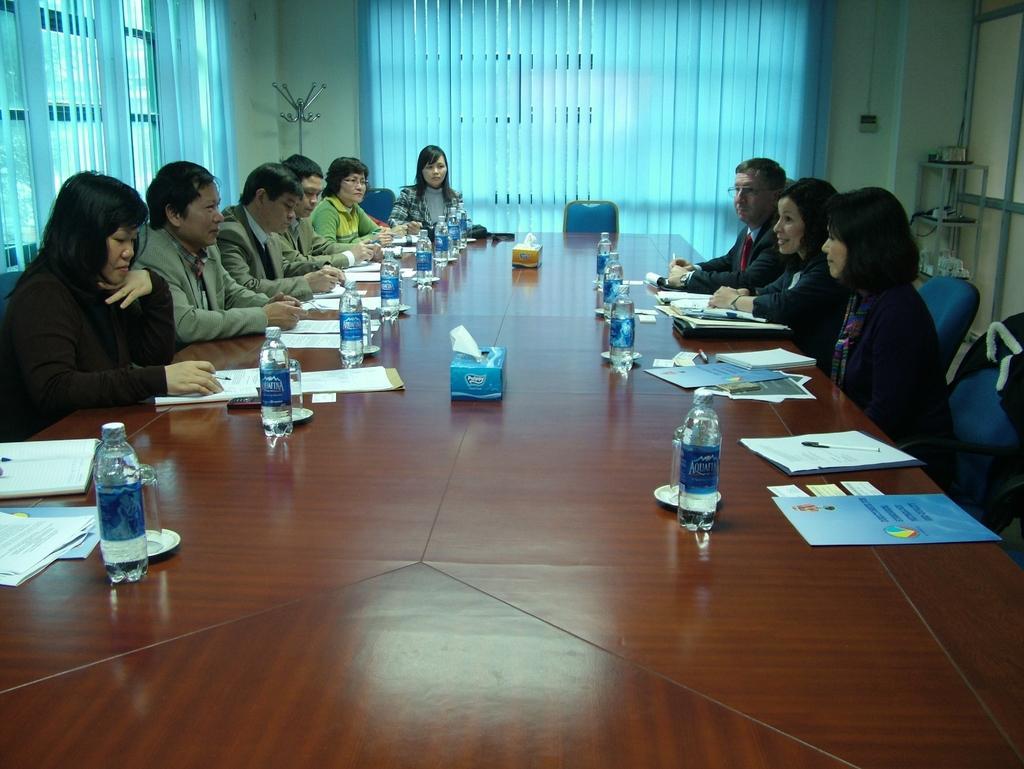In one or two sentences, can you explain what this image depicts? These people are sitting on chairs. On this table there are papers, tissue paper boxes, bottles, plates and glasses. Few people are holding pens. These are windows and window blinds. Corner of the room there is a rack filled with objects.  